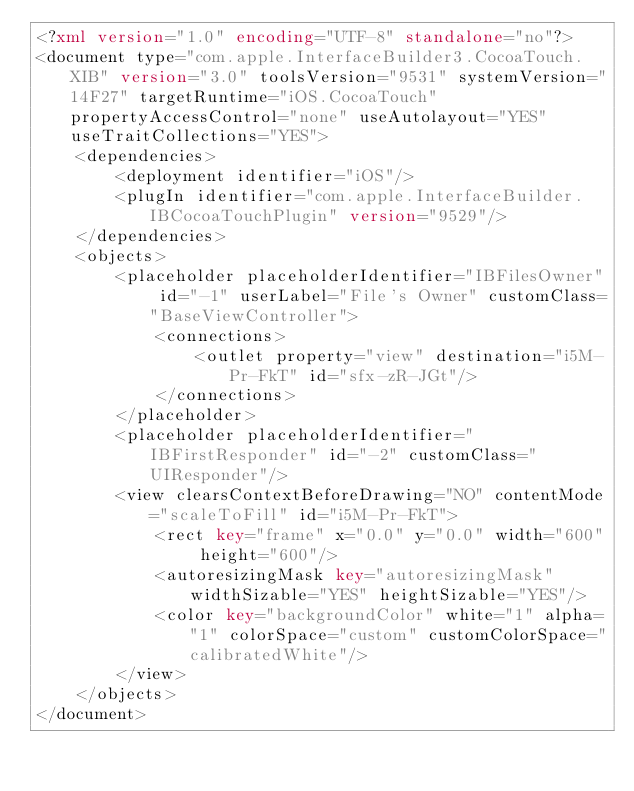<code> <loc_0><loc_0><loc_500><loc_500><_XML_><?xml version="1.0" encoding="UTF-8" standalone="no"?>
<document type="com.apple.InterfaceBuilder3.CocoaTouch.XIB" version="3.0" toolsVersion="9531" systemVersion="14F27" targetRuntime="iOS.CocoaTouch" propertyAccessControl="none" useAutolayout="YES" useTraitCollections="YES">
    <dependencies>
        <deployment identifier="iOS"/>
        <plugIn identifier="com.apple.InterfaceBuilder.IBCocoaTouchPlugin" version="9529"/>
    </dependencies>
    <objects>
        <placeholder placeholderIdentifier="IBFilesOwner" id="-1" userLabel="File's Owner" customClass="BaseViewController">
            <connections>
                <outlet property="view" destination="i5M-Pr-FkT" id="sfx-zR-JGt"/>
            </connections>
        </placeholder>
        <placeholder placeholderIdentifier="IBFirstResponder" id="-2" customClass="UIResponder"/>
        <view clearsContextBeforeDrawing="NO" contentMode="scaleToFill" id="i5M-Pr-FkT">
            <rect key="frame" x="0.0" y="0.0" width="600" height="600"/>
            <autoresizingMask key="autoresizingMask" widthSizable="YES" heightSizable="YES"/>
            <color key="backgroundColor" white="1" alpha="1" colorSpace="custom" customColorSpace="calibratedWhite"/>
        </view>
    </objects>
</document>
</code> 